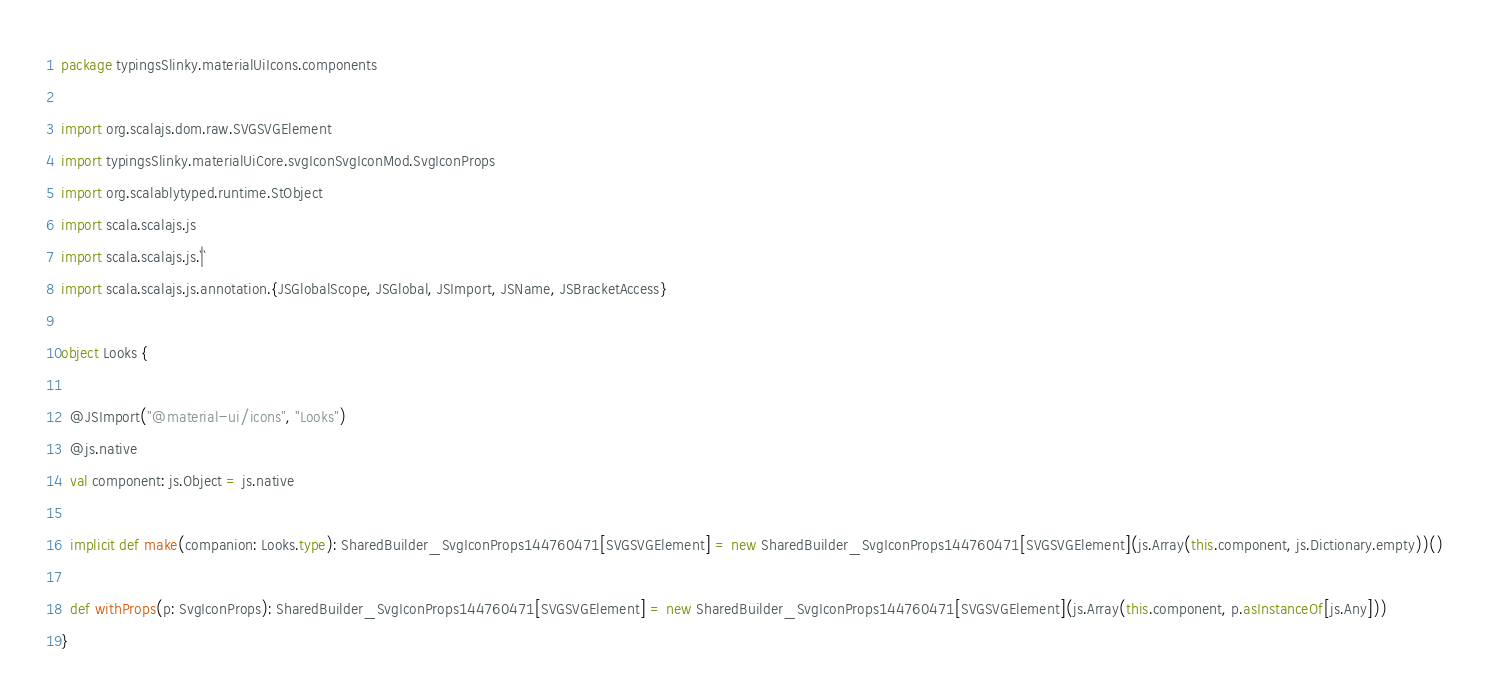<code> <loc_0><loc_0><loc_500><loc_500><_Scala_>package typingsSlinky.materialUiIcons.components

import org.scalajs.dom.raw.SVGSVGElement
import typingsSlinky.materialUiCore.svgIconSvgIconMod.SvgIconProps
import org.scalablytyped.runtime.StObject
import scala.scalajs.js
import scala.scalajs.js.`|`
import scala.scalajs.js.annotation.{JSGlobalScope, JSGlobal, JSImport, JSName, JSBracketAccess}

object Looks {
  
  @JSImport("@material-ui/icons", "Looks")
  @js.native
  val component: js.Object = js.native
  
  implicit def make(companion: Looks.type): SharedBuilder_SvgIconProps144760471[SVGSVGElement] = new SharedBuilder_SvgIconProps144760471[SVGSVGElement](js.Array(this.component, js.Dictionary.empty))()
  
  def withProps(p: SvgIconProps): SharedBuilder_SvgIconProps144760471[SVGSVGElement] = new SharedBuilder_SvgIconProps144760471[SVGSVGElement](js.Array(this.component, p.asInstanceOf[js.Any]))
}
</code> 